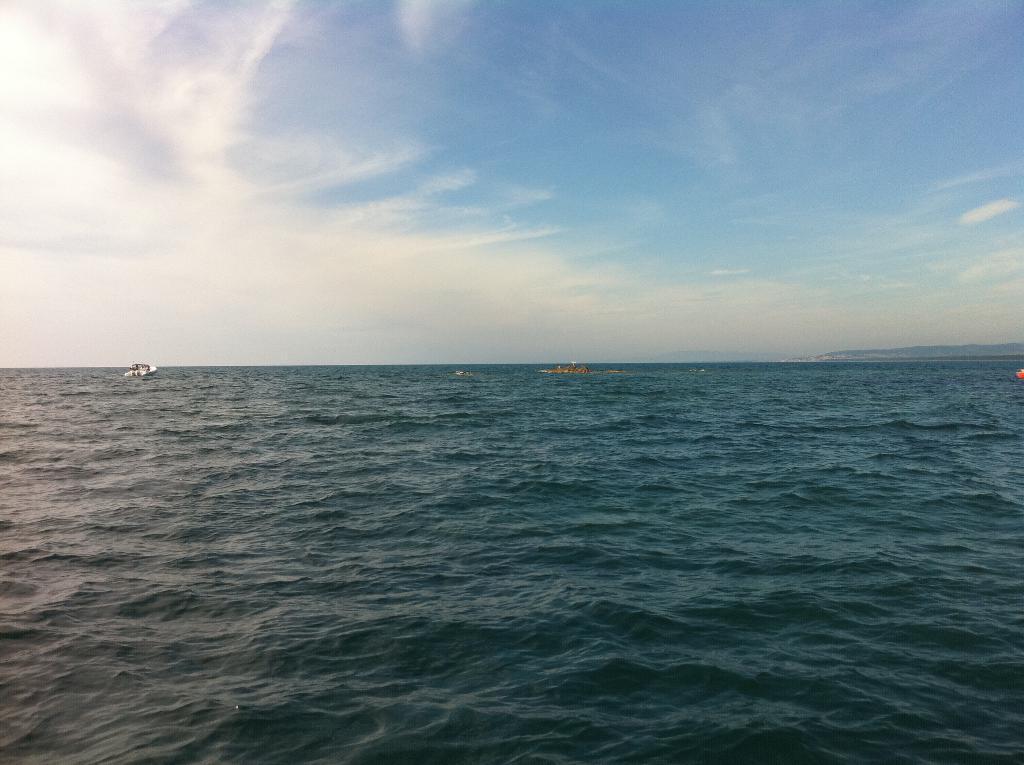In one or two sentences, can you explain what this image depicts? In this image there are boats on the water , and in the background there is sky. 